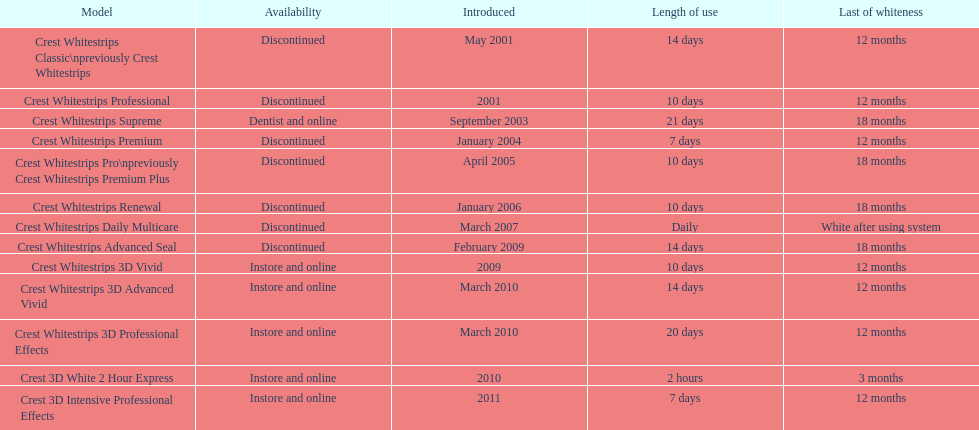Which model has the best 'use longevity' to 'whiteness retention' proportion? Crest Whitestrips Supreme. 